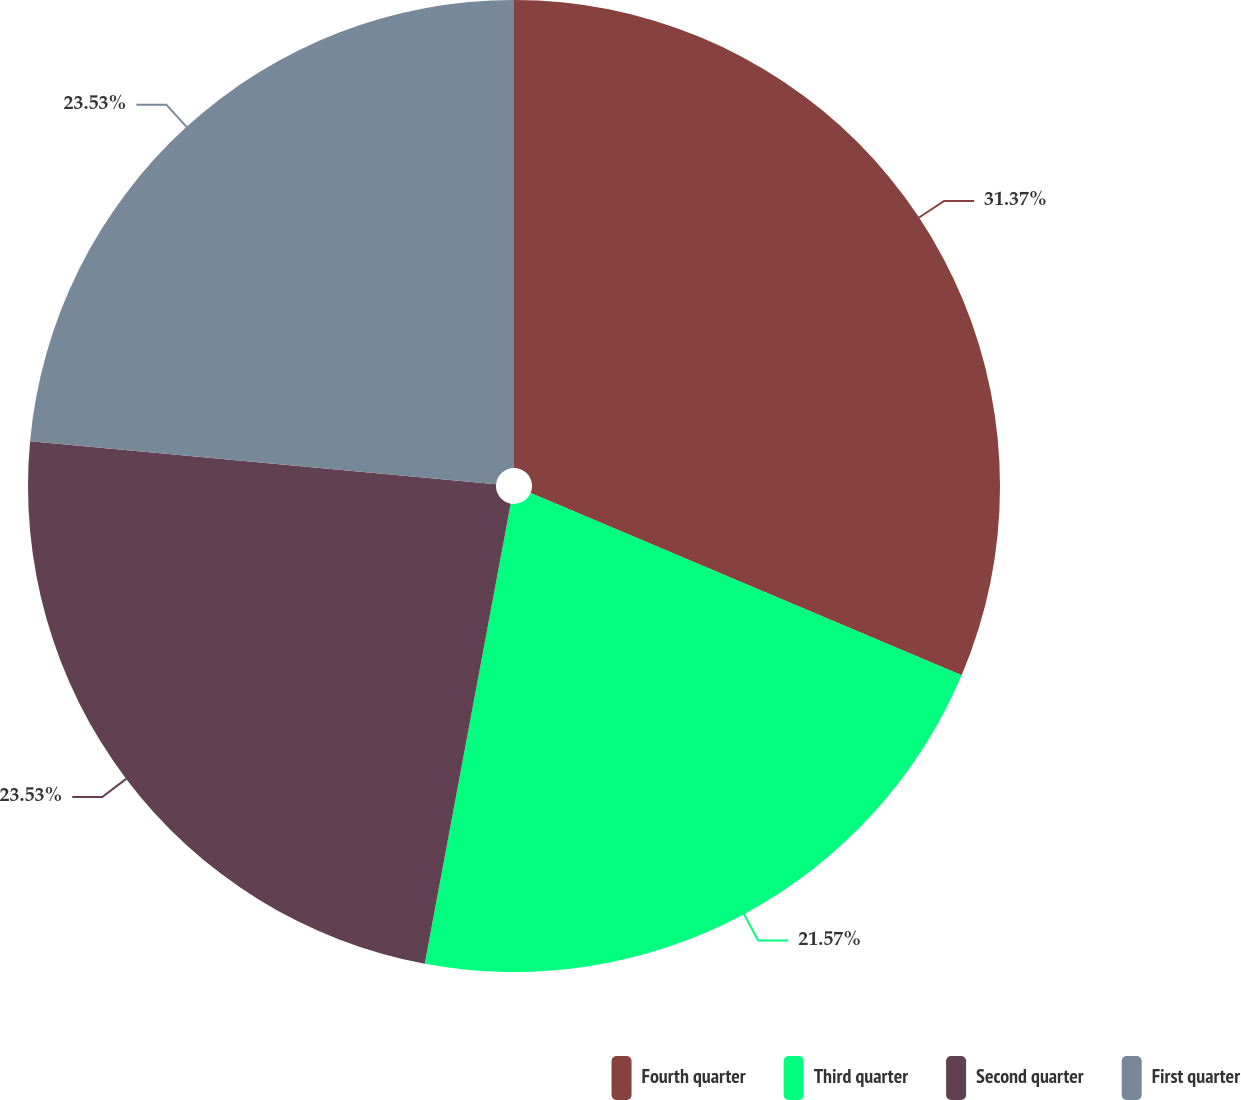Convert chart. <chart><loc_0><loc_0><loc_500><loc_500><pie_chart><fcel>Fourth quarter<fcel>Third quarter<fcel>Second quarter<fcel>First quarter<nl><fcel>31.37%<fcel>21.57%<fcel>23.53%<fcel>23.53%<nl></chart> 